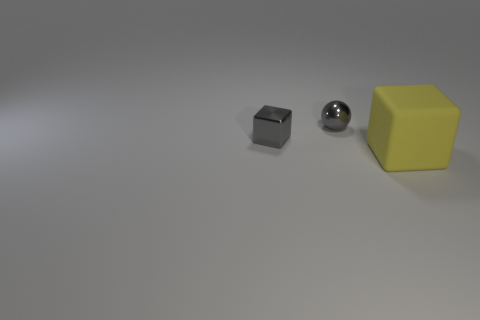Add 1 large matte cubes. How many objects exist? 4 Subtract all cubes. How many objects are left? 1 Add 1 big rubber blocks. How many big rubber blocks exist? 2 Subtract 0 cyan cubes. How many objects are left? 3 Subtract all matte cubes. Subtract all large gray shiny spheres. How many objects are left? 2 Add 3 small gray cubes. How many small gray cubes are left? 4 